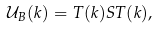Convert formula to latex. <formula><loc_0><loc_0><loc_500><loc_500>\mathcal { U } _ { B } ( k ) = T ( k ) S T ( k ) ,</formula> 